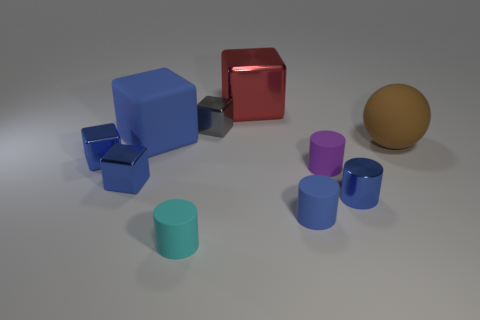How many blue blocks must be subtracted to get 1 blue blocks? 2 Subtract all green cylinders. How many blue cubes are left? 3 Subtract all red cubes. How many cubes are left? 4 Subtract all blue matte blocks. How many blocks are left? 4 Subtract all purple cubes. Subtract all brown spheres. How many cubes are left? 5 Subtract all spheres. How many objects are left? 9 Add 3 cyan matte things. How many cyan matte things are left? 4 Add 7 small brown rubber cylinders. How many small brown rubber cylinders exist? 7 Subtract 1 purple cylinders. How many objects are left? 9 Subtract all small yellow matte cubes. Subtract all cyan objects. How many objects are left? 9 